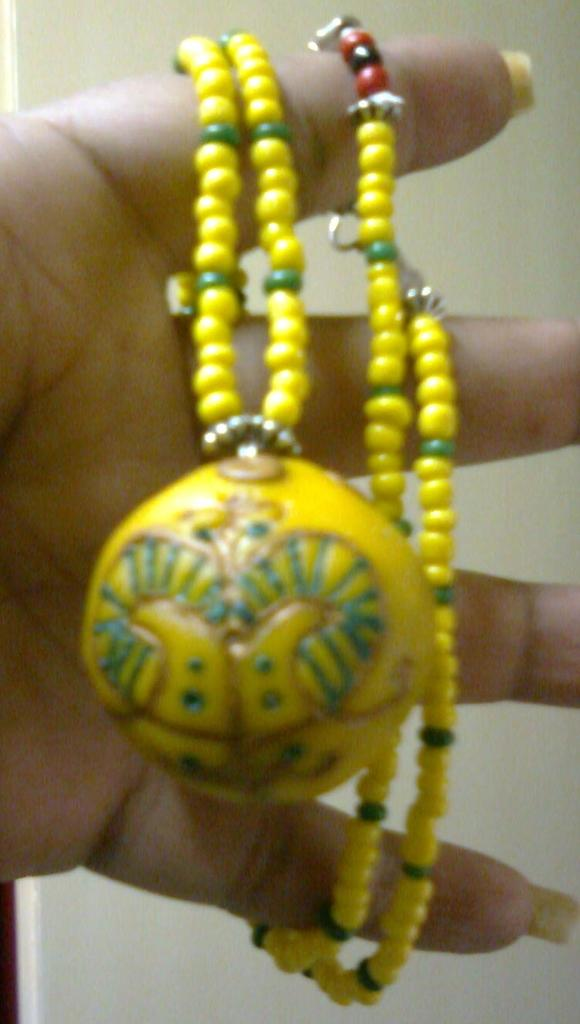What part of a person is visible in the image? There is a person's hand in the image. What type of accessory is present in the image? There is jewelry in the image. What color is the background of the image? The background of the image is white. What type of table is present in the image? There is no table present in the image; only a person's hand and jewelry are visible. 